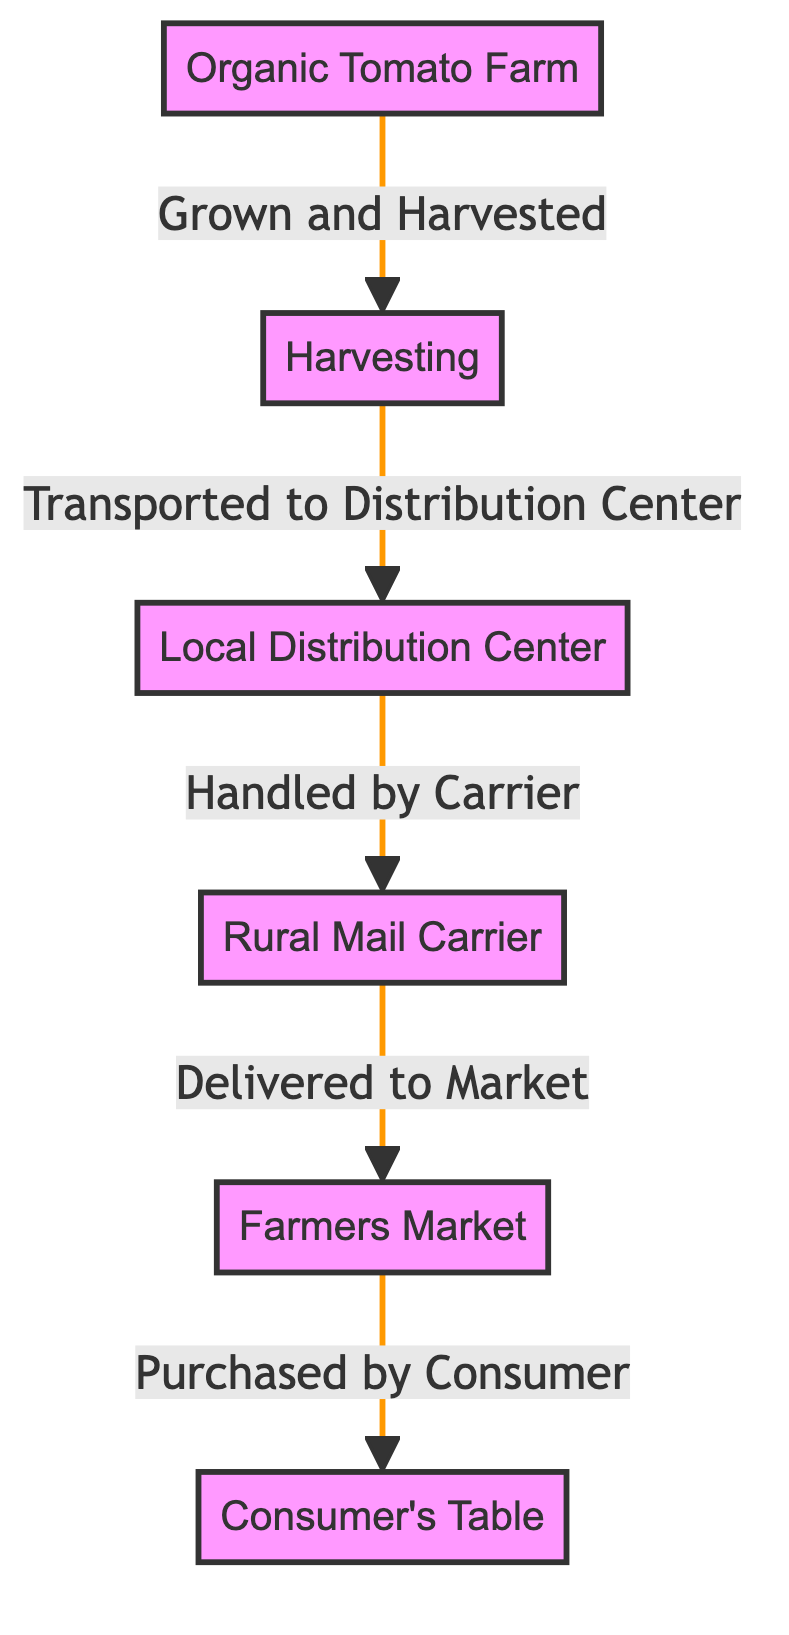What is the starting point in the food chain? The starting point is the first node labeled "Organic Tomato Farm," which represents where the tomatoes are grown before the harvesting process begins.
Answer: Organic Tomato Farm How many nodes are present in the diagram? The diagram consists of six distinct nodes that represent various stages in the food chain of the organic tomato.
Answer: 6 What is the node that represents the process of transportation after harvesting? "Local Distribution Center" is the node that illustrates where the tomatoes are transported after the harvesting process.
Answer: Local Distribution Center What is the final destination for the organic tomato? The final destination in the food chain is represented by the node labeled "Consumer's Table," which indicates where the tomatoes end up after all previous steps.
Answer: Consumer's Table Which entity handles the tomatoes before they reach the market? The "Rural Mail Carrier" is the entity that handles the tomatoes between the distribution center and the market, ensuring they reach consumers.
Answer: Rural Mail Carrier How many edges are there in the diagram? The diagram has five edges that represent the connections and flow of the organic tomatoes from one node to the next in the food chain.
Answer: 5 What action takes place at the second node? At the second node, "Harvesting," the organic tomatoes are gathered after they have ripened and are ready for transport.
Answer: Harvesting What relationship does the node "Harvesting" have with the "Organic Tomato Farm"? The relationship is that the "Organic Tomato Farm" provides the tomatoes, which are then harvested in the subsequent step indicated by the "Harvesting" node.
Answer: Grown and Harvested What are the two processes directly involved in moving the tomatoes from the farm to the market? The processes are "Harvesting" and "Transported to Distribution Center," which represent the initial steps in the journey of the tomatoes.
Answer: Harvesting, Transported to Distribution Center 